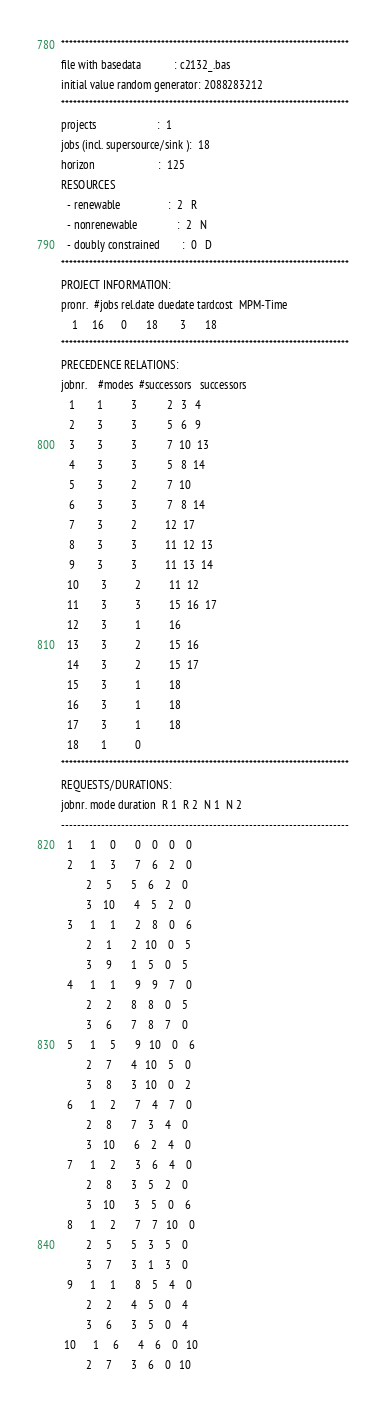Convert code to text. <code><loc_0><loc_0><loc_500><loc_500><_ObjectiveC_>************************************************************************
file with basedata            : c2132_.bas
initial value random generator: 2088283212
************************************************************************
projects                      :  1
jobs (incl. supersource/sink ):  18
horizon                       :  125
RESOURCES
  - renewable                 :  2   R
  - nonrenewable              :  2   N
  - doubly constrained        :  0   D
************************************************************************
PROJECT INFORMATION:
pronr.  #jobs rel.date duedate tardcost  MPM-Time
    1     16      0       18        3       18
************************************************************************
PRECEDENCE RELATIONS:
jobnr.    #modes  #successors   successors
   1        1          3           2   3   4
   2        3          3           5   6   9
   3        3          3           7  10  13
   4        3          3           5   8  14
   5        3          2           7  10
   6        3          3           7   8  14
   7        3          2          12  17
   8        3          3          11  12  13
   9        3          3          11  13  14
  10        3          2          11  12
  11        3          3          15  16  17
  12        3          1          16
  13        3          2          15  16
  14        3          2          15  17
  15        3          1          18
  16        3          1          18
  17        3          1          18
  18        1          0        
************************************************************************
REQUESTS/DURATIONS:
jobnr. mode duration  R 1  R 2  N 1  N 2
------------------------------------------------------------------------
  1      1     0       0    0    0    0
  2      1     3       7    6    2    0
         2     5       5    6    2    0
         3    10       4    5    2    0
  3      1     1       2    8    0    6
         2     1       2   10    0    5
         3     9       1    5    0    5
  4      1     1       9    9    7    0
         2     2       8    8    0    5
         3     6       7    8    7    0
  5      1     5       9   10    0    6
         2     7       4   10    5    0
         3     8       3   10    0    2
  6      1     2       7    4    7    0
         2     8       7    3    4    0
         3    10       6    2    4    0
  7      1     2       3    6    4    0
         2     8       3    5    2    0
         3    10       3    5    0    6
  8      1     2       7    7   10    0
         2     5       5    3    5    0
         3     7       3    1    3    0
  9      1     1       8    5    4    0
         2     2       4    5    0    4
         3     6       3    5    0    4
 10      1     6       4    6    0   10
         2     7       3    6    0   10</code> 